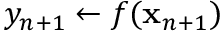<formula> <loc_0><loc_0><loc_500><loc_500>y _ { n + 1 } \leftarrow f ( x _ { n + 1 } )</formula> 